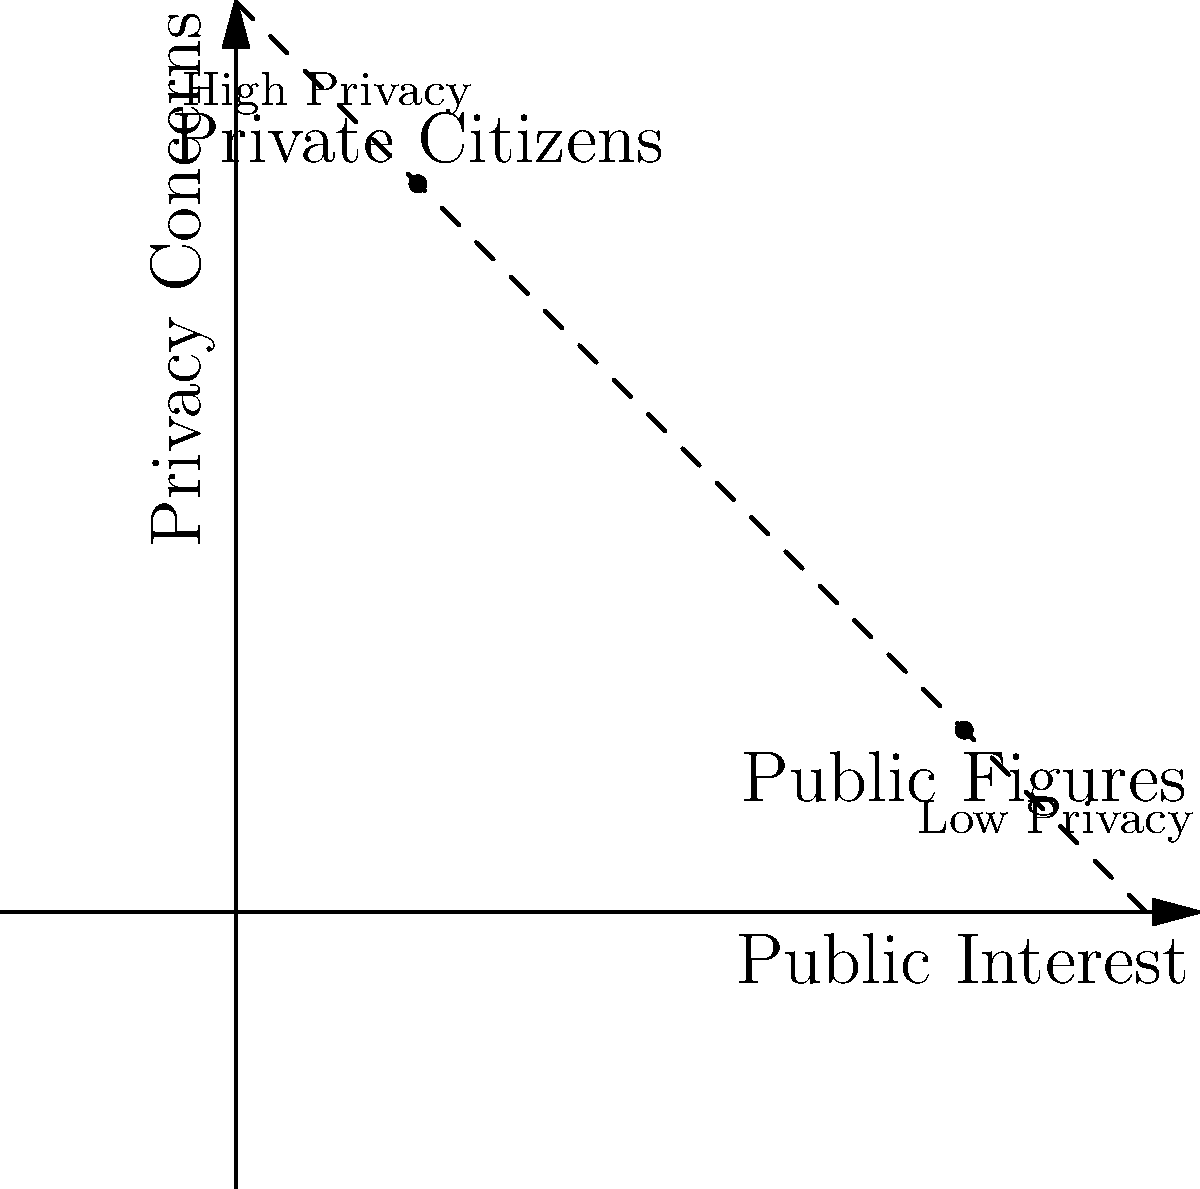As a journalist using facial recognition technology to classify images, how would you approach the ethical dilemma of distinguishing between public figures and private citizens in your reporting, considering the balance between public interest and individual privacy? 1. Understand the ethical framework:
   - Journalists have a duty to inform the public
   - Individuals have a right to privacy

2. Analyze the graph:
   - X-axis represents public interest
   - Y-axis represents privacy concerns
   - Decision boundary (dashed line) separates high and low privacy regions

3. Consider the position of public figures:
   - Lower on the privacy scale
   - Higher on the public interest scale
   - Generally more acceptable to report on

4. Consider the position of private citizens:
   - Higher on the privacy scale
   - Lower on the public interest scale
   - Generally should be afforded more privacy

5. Evaluate the use of facial recognition:
   - Can help identify public figures quickly
   - Poses risks to privacy when used on private citizens

6. Develop an ethical approach:
   - Use facial recognition primarily for public figures
   - Implement stricter guidelines for private citizens
   - Ensure consent and relevance before publishing private citizens' images

7. Balance journalistic duty with privacy:
   - Report on public figures when in the public interest
   - Limit exposure of private citizens unless critically relevant to the story
   - Always consider the potential impact on individuals' privacy

8. Establish clear policies:
   - Create guidelines for using facial recognition technology
   - Set thresholds for when to publish images of private citizens
   - Regularly review and update policies as technology evolves
Answer: Use facial recognition judiciously, prioritizing public figures and implementing strict privacy safeguards for private citizens. 